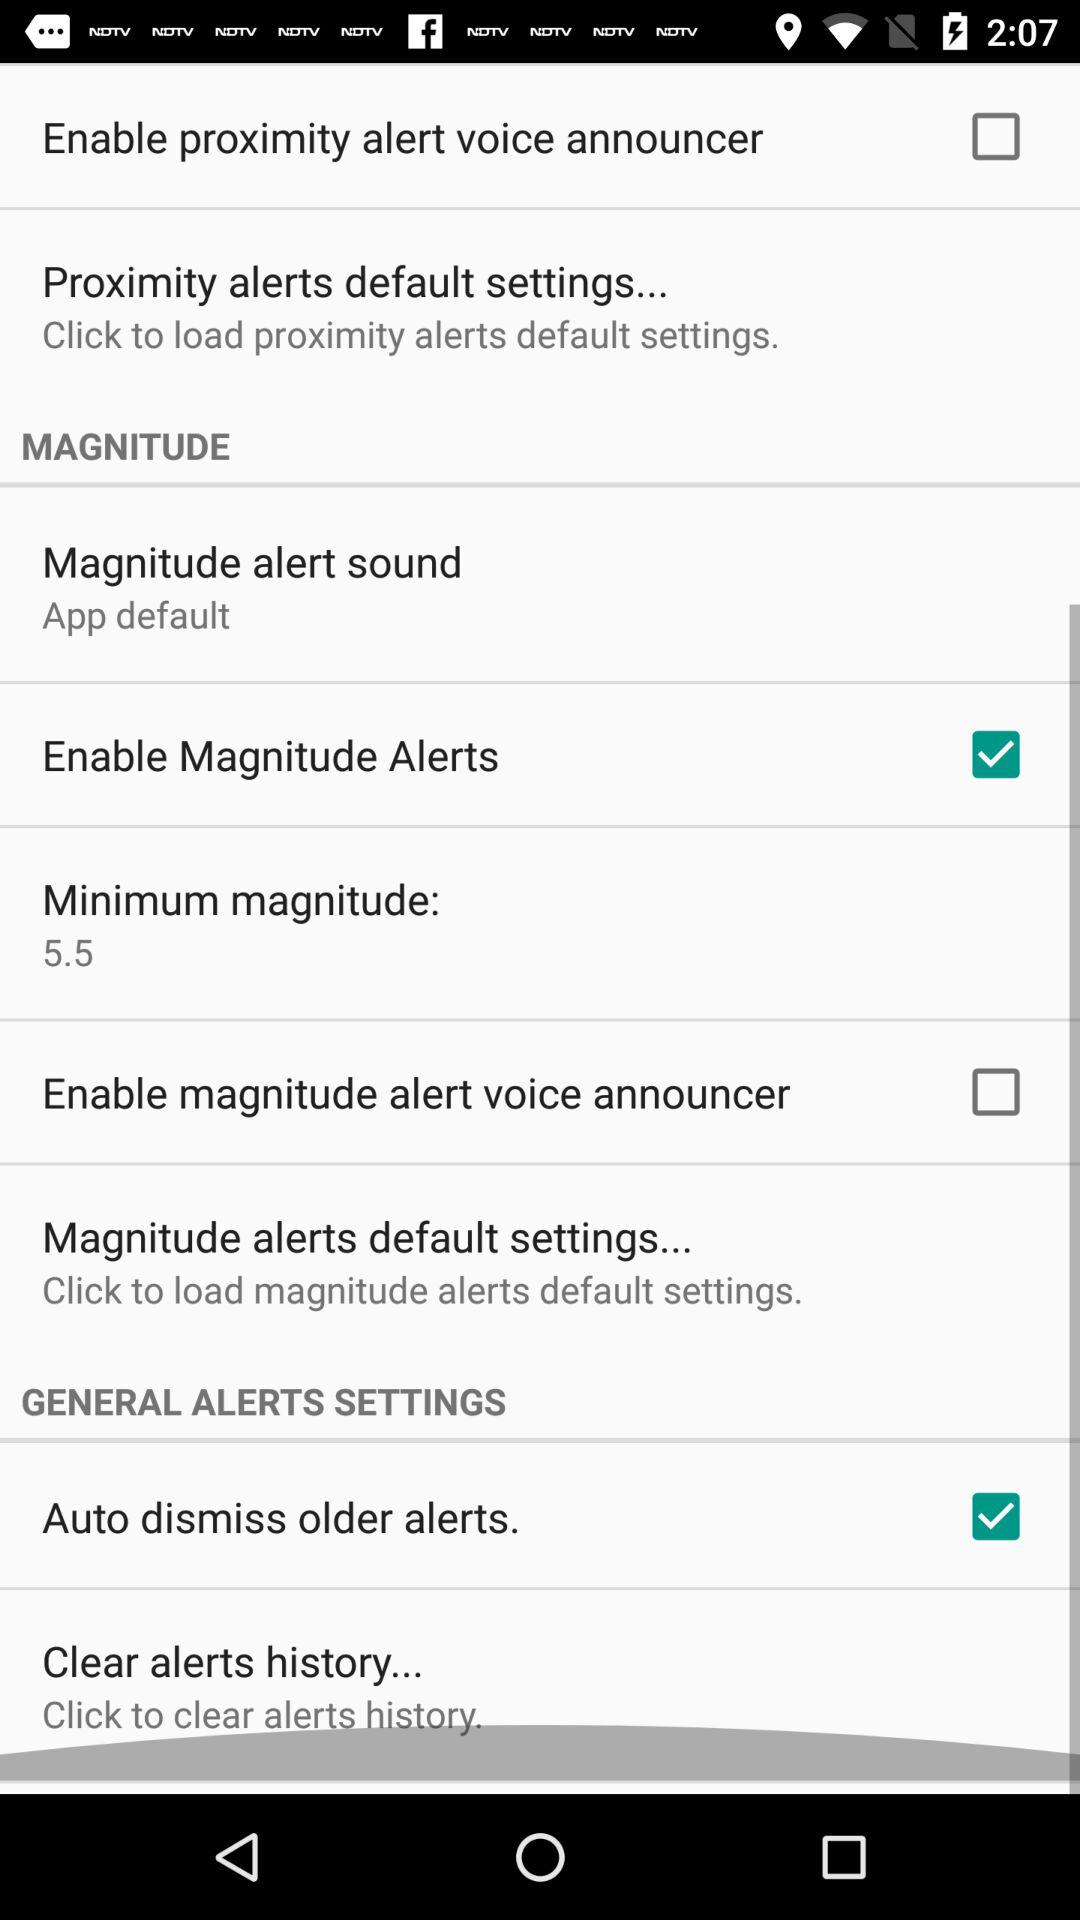What is the selected minimum magnitude? The selected minimum magnitude is 5.5. 